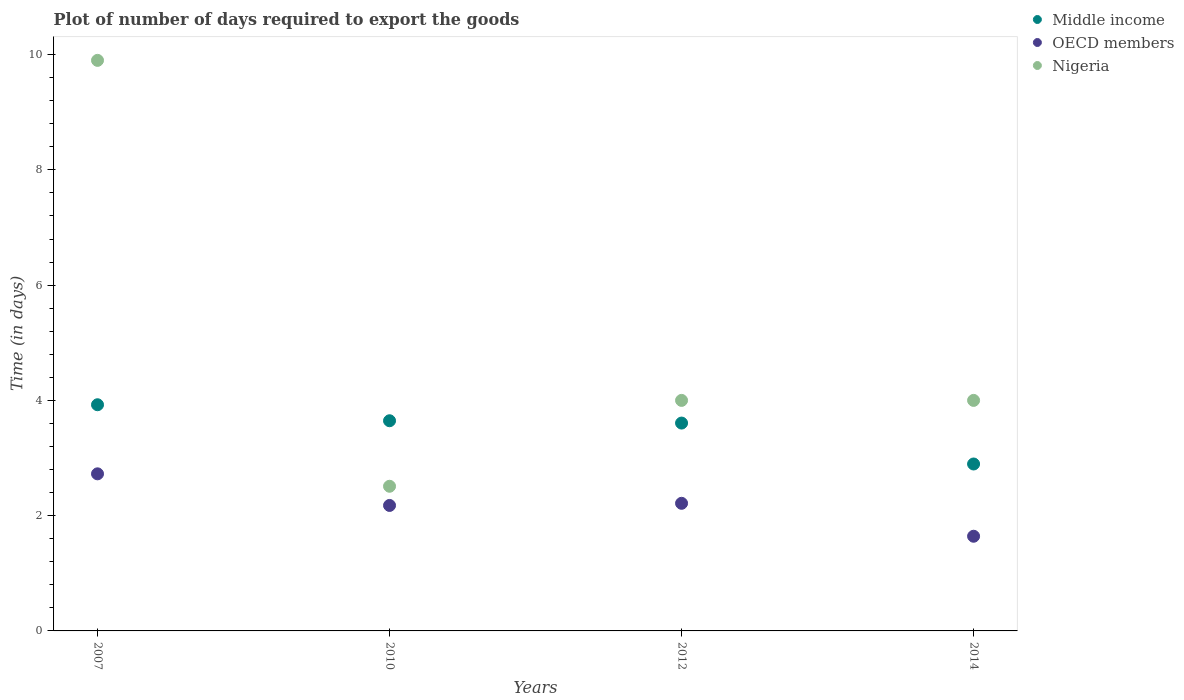What is the time required to export goods in OECD members in 2012?
Your answer should be very brief. 2.21. Across all years, what is the maximum time required to export goods in Nigeria?
Offer a very short reply. 9.9. Across all years, what is the minimum time required to export goods in OECD members?
Keep it short and to the point. 1.64. In which year was the time required to export goods in OECD members maximum?
Your answer should be compact. 2007. What is the total time required to export goods in Nigeria in the graph?
Offer a terse response. 20.41. What is the difference between the time required to export goods in OECD members in 2010 and that in 2014?
Give a very brief answer. 0.53. What is the difference between the time required to export goods in Nigeria in 2012 and the time required to export goods in OECD members in 2007?
Ensure brevity in your answer.  1.27. What is the average time required to export goods in Nigeria per year?
Provide a short and direct response. 5.1. In the year 2007, what is the difference between the time required to export goods in OECD members and time required to export goods in Nigeria?
Your response must be concise. -7.17. What is the ratio of the time required to export goods in Nigeria in 2007 to that in 2010?
Make the answer very short. 3.94. Is the time required to export goods in Nigeria in 2010 less than that in 2014?
Give a very brief answer. Yes. Is the difference between the time required to export goods in OECD members in 2007 and 2014 greater than the difference between the time required to export goods in Nigeria in 2007 and 2014?
Your answer should be compact. No. What is the difference between the highest and the second highest time required to export goods in Nigeria?
Ensure brevity in your answer.  5.9. What is the difference between the highest and the lowest time required to export goods in OECD members?
Make the answer very short. 1.08. Is it the case that in every year, the sum of the time required to export goods in OECD members and time required to export goods in Middle income  is greater than the time required to export goods in Nigeria?
Your response must be concise. No. Is the time required to export goods in OECD members strictly less than the time required to export goods in Nigeria over the years?
Keep it short and to the point. Yes. How many dotlines are there?
Give a very brief answer. 3. How many years are there in the graph?
Provide a succinct answer. 4. What is the difference between two consecutive major ticks on the Y-axis?
Make the answer very short. 2. Does the graph contain any zero values?
Provide a succinct answer. No. Where does the legend appear in the graph?
Make the answer very short. Top right. How are the legend labels stacked?
Your response must be concise. Vertical. What is the title of the graph?
Offer a terse response. Plot of number of days required to export the goods. What is the label or title of the Y-axis?
Provide a succinct answer. Time (in days). What is the Time (in days) in Middle income in 2007?
Make the answer very short. 3.92. What is the Time (in days) of OECD members in 2007?
Provide a short and direct response. 2.73. What is the Time (in days) of Nigeria in 2007?
Make the answer very short. 9.9. What is the Time (in days) of Middle income in 2010?
Ensure brevity in your answer.  3.65. What is the Time (in days) in OECD members in 2010?
Your answer should be compact. 2.18. What is the Time (in days) of Nigeria in 2010?
Make the answer very short. 2.51. What is the Time (in days) of Middle income in 2012?
Provide a short and direct response. 3.61. What is the Time (in days) of OECD members in 2012?
Your response must be concise. 2.21. What is the Time (in days) of Nigeria in 2012?
Offer a terse response. 4. What is the Time (in days) in Middle income in 2014?
Offer a very short reply. 2.9. What is the Time (in days) in OECD members in 2014?
Give a very brief answer. 1.64. What is the Time (in days) of Nigeria in 2014?
Your response must be concise. 4. Across all years, what is the maximum Time (in days) in Middle income?
Your answer should be very brief. 3.92. Across all years, what is the maximum Time (in days) of OECD members?
Your answer should be very brief. 2.73. Across all years, what is the minimum Time (in days) of Middle income?
Your answer should be very brief. 2.9. Across all years, what is the minimum Time (in days) of OECD members?
Provide a succinct answer. 1.64. Across all years, what is the minimum Time (in days) of Nigeria?
Your response must be concise. 2.51. What is the total Time (in days) in Middle income in the graph?
Your response must be concise. 14.07. What is the total Time (in days) in OECD members in the graph?
Keep it short and to the point. 8.76. What is the total Time (in days) of Nigeria in the graph?
Offer a terse response. 20.41. What is the difference between the Time (in days) of Middle income in 2007 and that in 2010?
Your answer should be very brief. 0.28. What is the difference between the Time (in days) in OECD members in 2007 and that in 2010?
Ensure brevity in your answer.  0.55. What is the difference between the Time (in days) in Nigeria in 2007 and that in 2010?
Give a very brief answer. 7.39. What is the difference between the Time (in days) in Middle income in 2007 and that in 2012?
Offer a very short reply. 0.32. What is the difference between the Time (in days) in OECD members in 2007 and that in 2012?
Offer a very short reply. 0.51. What is the difference between the Time (in days) of Nigeria in 2007 and that in 2012?
Offer a very short reply. 5.9. What is the difference between the Time (in days) in Middle income in 2007 and that in 2014?
Your response must be concise. 1.03. What is the difference between the Time (in days) in OECD members in 2007 and that in 2014?
Provide a short and direct response. 1.08. What is the difference between the Time (in days) of Middle income in 2010 and that in 2012?
Offer a terse response. 0.04. What is the difference between the Time (in days) of OECD members in 2010 and that in 2012?
Offer a very short reply. -0.04. What is the difference between the Time (in days) in Nigeria in 2010 and that in 2012?
Make the answer very short. -1.49. What is the difference between the Time (in days) of Middle income in 2010 and that in 2014?
Give a very brief answer. 0.75. What is the difference between the Time (in days) of OECD members in 2010 and that in 2014?
Give a very brief answer. 0.53. What is the difference between the Time (in days) of Nigeria in 2010 and that in 2014?
Give a very brief answer. -1.49. What is the difference between the Time (in days) in Middle income in 2012 and that in 2014?
Your response must be concise. 0.71. What is the difference between the Time (in days) of OECD members in 2012 and that in 2014?
Offer a very short reply. 0.57. What is the difference between the Time (in days) of Middle income in 2007 and the Time (in days) of OECD members in 2010?
Your response must be concise. 1.75. What is the difference between the Time (in days) in Middle income in 2007 and the Time (in days) in Nigeria in 2010?
Offer a terse response. 1.41. What is the difference between the Time (in days) in OECD members in 2007 and the Time (in days) in Nigeria in 2010?
Keep it short and to the point. 0.22. What is the difference between the Time (in days) in Middle income in 2007 and the Time (in days) in OECD members in 2012?
Your answer should be very brief. 1.71. What is the difference between the Time (in days) in Middle income in 2007 and the Time (in days) in Nigeria in 2012?
Your answer should be compact. -0.08. What is the difference between the Time (in days) in OECD members in 2007 and the Time (in days) in Nigeria in 2012?
Your response must be concise. -1.27. What is the difference between the Time (in days) of Middle income in 2007 and the Time (in days) of OECD members in 2014?
Keep it short and to the point. 2.28. What is the difference between the Time (in days) in Middle income in 2007 and the Time (in days) in Nigeria in 2014?
Provide a short and direct response. -0.08. What is the difference between the Time (in days) of OECD members in 2007 and the Time (in days) of Nigeria in 2014?
Provide a short and direct response. -1.27. What is the difference between the Time (in days) in Middle income in 2010 and the Time (in days) in OECD members in 2012?
Provide a succinct answer. 1.43. What is the difference between the Time (in days) of Middle income in 2010 and the Time (in days) of Nigeria in 2012?
Provide a succinct answer. -0.35. What is the difference between the Time (in days) of OECD members in 2010 and the Time (in days) of Nigeria in 2012?
Your response must be concise. -1.82. What is the difference between the Time (in days) of Middle income in 2010 and the Time (in days) of OECD members in 2014?
Provide a short and direct response. 2. What is the difference between the Time (in days) of Middle income in 2010 and the Time (in days) of Nigeria in 2014?
Your answer should be very brief. -0.35. What is the difference between the Time (in days) in OECD members in 2010 and the Time (in days) in Nigeria in 2014?
Make the answer very short. -1.82. What is the difference between the Time (in days) of Middle income in 2012 and the Time (in days) of OECD members in 2014?
Your answer should be compact. 1.96. What is the difference between the Time (in days) in Middle income in 2012 and the Time (in days) in Nigeria in 2014?
Provide a short and direct response. -0.39. What is the difference between the Time (in days) in OECD members in 2012 and the Time (in days) in Nigeria in 2014?
Provide a short and direct response. -1.79. What is the average Time (in days) of Middle income per year?
Offer a terse response. 3.52. What is the average Time (in days) of OECD members per year?
Make the answer very short. 2.19. What is the average Time (in days) of Nigeria per year?
Your answer should be very brief. 5.1. In the year 2007, what is the difference between the Time (in days) of Middle income and Time (in days) of OECD members?
Provide a short and direct response. 1.2. In the year 2007, what is the difference between the Time (in days) of Middle income and Time (in days) of Nigeria?
Offer a very short reply. -5.98. In the year 2007, what is the difference between the Time (in days) of OECD members and Time (in days) of Nigeria?
Provide a short and direct response. -7.17. In the year 2010, what is the difference between the Time (in days) of Middle income and Time (in days) of OECD members?
Your answer should be very brief. 1.47. In the year 2010, what is the difference between the Time (in days) in Middle income and Time (in days) in Nigeria?
Give a very brief answer. 1.14. In the year 2010, what is the difference between the Time (in days) of OECD members and Time (in days) of Nigeria?
Make the answer very short. -0.33. In the year 2012, what is the difference between the Time (in days) of Middle income and Time (in days) of OECD members?
Your answer should be compact. 1.39. In the year 2012, what is the difference between the Time (in days) of Middle income and Time (in days) of Nigeria?
Keep it short and to the point. -0.39. In the year 2012, what is the difference between the Time (in days) of OECD members and Time (in days) of Nigeria?
Offer a terse response. -1.79. In the year 2014, what is the difference between the Time (in days) in Middle income and Time (in days) in OECD members?
Offer a very short reply. 1.25. In the year 2014, what is the difference between the Time (in days) in Middle income and Time (in days) in Nigeria?
Your answer should be very brief. -1.1. In the year 2014, what is the difference between the Time (in days) of OECD members and Time (in days) of Nigeria?
Give a very brief answer. -2.36. What is the ratio of the Time (in days) of Middle income in 2007 to that in 2010?
Your response must be concise. 1.08. What is the ratio of the Time (in days) of OECD members in 2007 to that in 2010?
Offer a terse response. 1.25. What is the ratio of the Time (in days) of Nigeria in 2007 to that in 2010?
Keep it short and to the point. 3.94. What is the ratio of the Time (in days) of Middle income in 2007 to that in 2012?
Provide a short and direct response. 1.09. What is the ratio of the Time (in days) in OECD members in 2007 to that in 2012?
Offer a terse response. 1.23. What is the ratio of the Time (in days) in Nigeria in 2007 to that in 2012?
Ensure brevity in your answer.  2.48. What is the ratio of the Time (in days) of Middle income in 2007 to that in 2014?
Make the answer very short. 1.35. What is the ratio of the Time (in days) of OECD members in 2007 to that in 2014?
Your response must be concise. 1.66. What is the ratio of the Time (in days) of Nigeria in 2007 to that in 2014?
Offer a terse response. 2.48. What is the ratio of the Time (in days) of Middle income in 2010 to that in 2012?
Your response must be concise. 1.01. What is the ratio of the Time (in days) in OECD members in 2010 to that in 2012?
Your answer should be very brief. 0.98. What is the ratio of the Time (in days) in Nigeria in 2010 to that in 2012?
Your response must be concise. 0.63. What is the ratio of the Time (in days) in Middle income in 2010 to that in 2014?
Offer a very short reply. 1.26. What is the ratio of the Time (in days) in OECD members in 2010 to that in 2014?
Offer a terse response. 1.33. What is the ratio of the Time (in days) in Nigeria in 2010 to that in 2014?
Give a very brief answer. 0.63. What is the ratio of the Time (in days) of Middle income in 2012 to that in 2014?
Offer a very short reply. 1.25. What is the ratio of the Time (in days) in OECD members in 2012 to that in 2014?
Provide a succinct answer. 1.35. What is the difference between the highest and the second highest Time (in days) in Middle income?
Provide a short and direct response. 0.28. What is the difference between the highest and the second highest Time (in days) in OECD members?
Make the answer very short. 0.51. What is the difference between the highest and the second highest Time (in days) of Nigeria?
Offer a terse response. 5.9. What is the difference between the highest and the lowest Time (in days) of Middle income?
Give a very brief answer. 1.03. What is the difference between the highest and the lowest Time (in days) in OECD members?
Make the answer very short. 1.08. What is the difference between the highest and the lowest Time (in days) in Nigeria?
Ensure brevity in your answer.  7.39. 